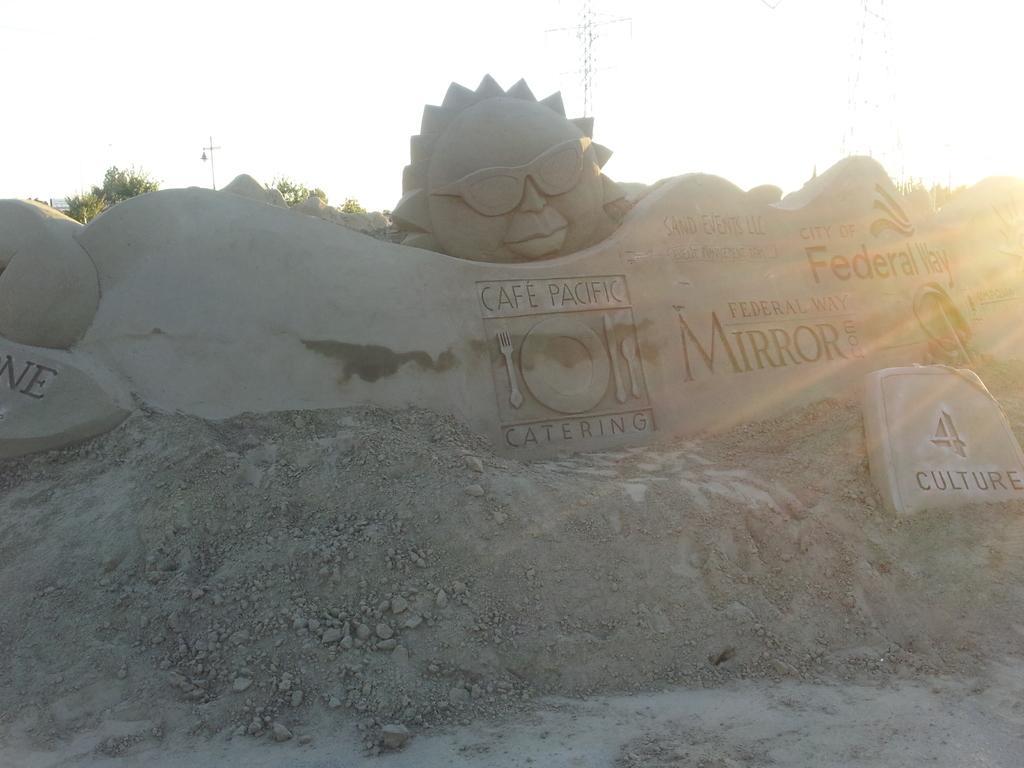In one or two sentences, can you explain what this image depicts? In this image we can see the sand sculpture with some text on it. In the background, we can see trees and sky. 